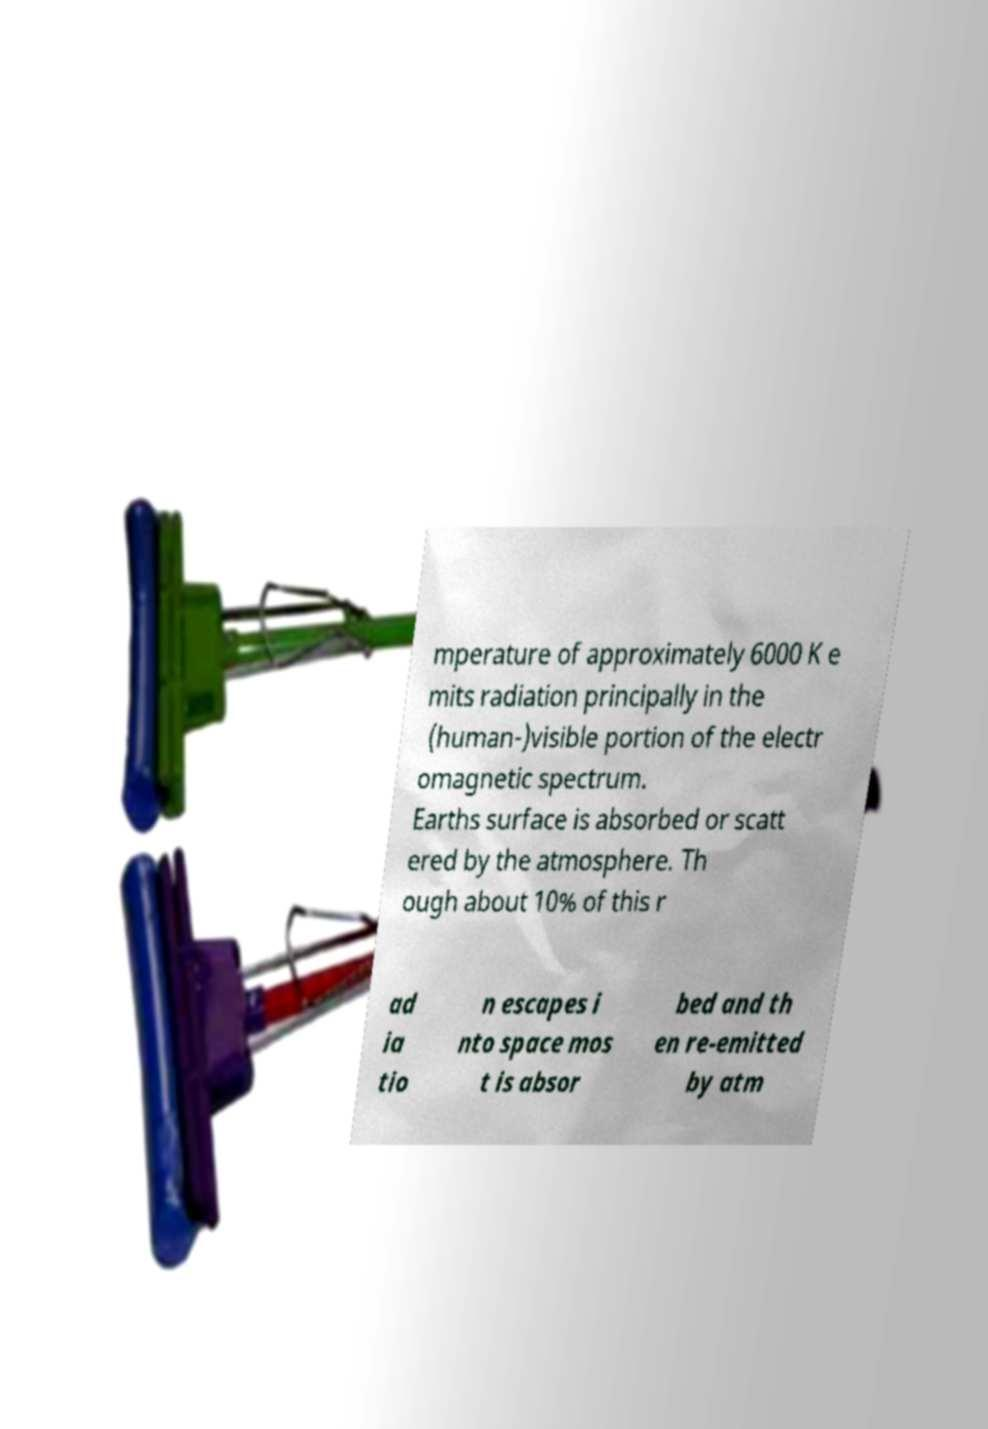Can you read and provide the text displayed in the image?This photo seems to have some interesting text. Can you extract and type it out for me? mperature of approximately 6000 K e mits radiation principally in the (human-)visible portion of the electr omagnetic spectrum. Earths surface is absorbed or scatt ered by the atmosphere. Th ough about 10% of this r ad ia tio n escapes i nto space mos t is absor bed and th en re-emitted by atm 